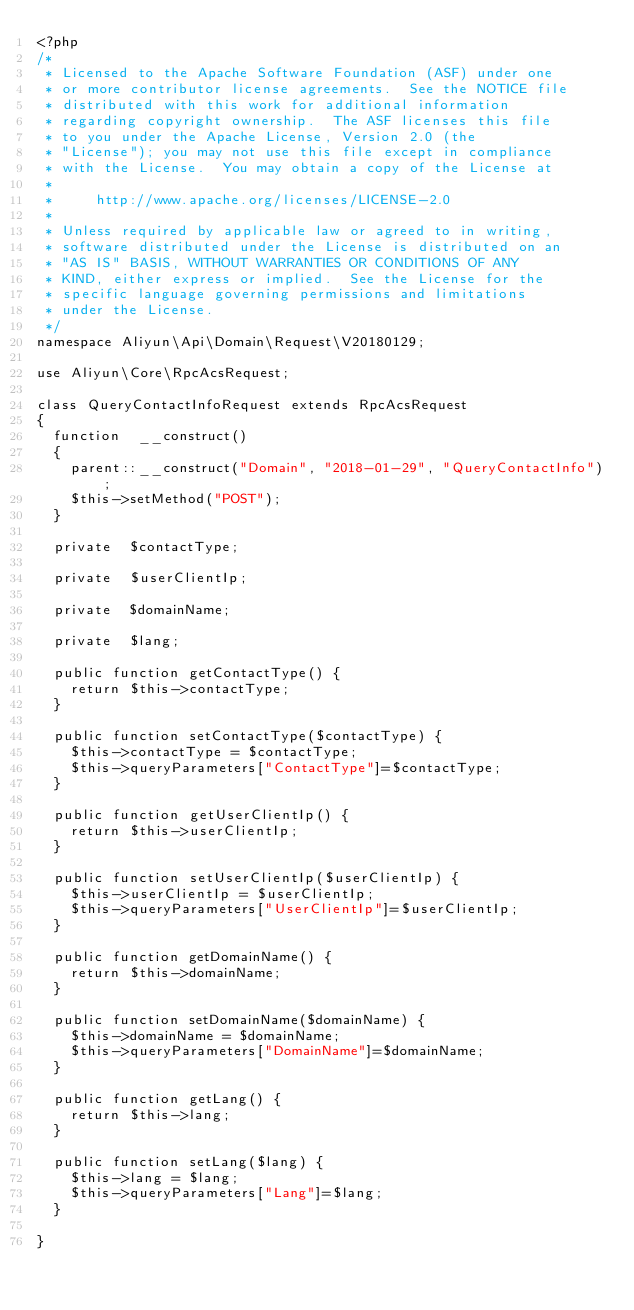Convert code to text. <code><loc_0><loc_0><loc_500><loc_500><_PHP_><?php
/*
 * Licensed to the Apache Software Foundation (ASF) under one
 * or more contributor license agreements.  See the NOTICE file
 * distributed with this work for additional information
 * regarding copyright ownership.  The ASF licenses this file
 * to you under the Apache License, Version 2.0 (the
 * "License"); you may not use this file except in compliance
 * with the License.  You may obtain a copy of the License at
 *
 *     http://www.apache.org/licenses/LICENSE-2.0
 *
 * Unless required by applicable law or agreed to in writing,
 * software distributed under the License is distributed on an
 * "AS IS" BASIS, WITHOUT WARRANTIES OR CONDITIONS OF ANY
 * KIND, either express or implied.  See the License for the
 * specific language governing permissions and limitations
 * under the License.
 */
namespace Aliyun\Api\Domain\Request\V20180129;

use Aliyun\Core\RpcAcsRequest;

class QueryContactInfoRequest extends RpcAcsRequest
{
	function  __construct()
	{
		parent::__construct("Domain", "2018-01-29", "QueryContactInfo");
		$this->setMethod("POST");
	}

	private  $contactType;

	private  $userClientIp;

	private  $domainName;

	private  $lang;

	public function getContactType() {
		return $this->contactType;
	}

	public function setContactType($contactType) {
		$this->contactType = $contactType;
		$this->queryParameters["ContactType"]=$contactType;
	}

	public function getUserClientIp() {
		return $this->userClientIp;
	}

	public function setUserClientIp($userClientIp) {
		$this->userClientIp = $userClientIp;
		$this->queryParameters["UserClientIp"]=$userClientIp;
	}

	public function getDomainName() {
		return $this->domainName;
	}

	public function setDomainName($domainName) {
		$this->domainName = $domainName;
		$this->queryParameters["DomainName"]=$domainName;
	}

	public function getLang() {
		return $this->lang;
	}

	public function setLang($lang) {
		$this->lang = $lang;
		$this->queryParameters["Lang"]=$lang;
	}
	
}</code> 